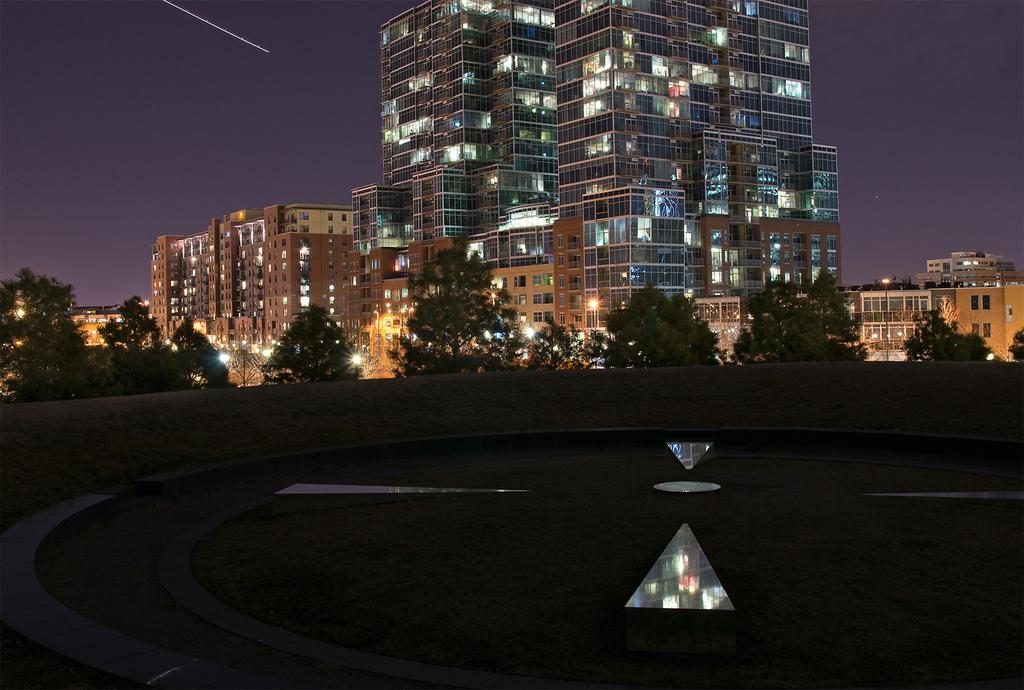What type of natural elements can be seen in the image? There are trees in the image. What artificial elements can be seen in the image? There are lights and buildings in the image. What part of the natural environment is visible in the image? The sky is visible in the image. How would you describe the overall lighting in the image? The image appears to be slightly dark. Is there any blood visible on the trees in the image? There is no blood present in the image; it features trees, lights, buildings, and a sky. Can you see a beggar in the image? There is no beggar present in the image. 